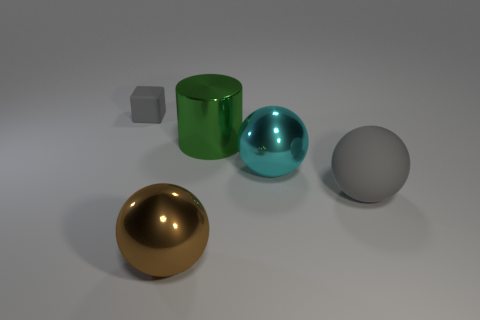Can you describe the position of the objects in the image? Certainly! In the image, we see a collection of geometric shapes positioned on a flat surface against a light background. Starting from the left, we have a golden sphere with a reflective surface, followed by a matte green cylinder, and next to it is a shiny light blue sphere. To the far right, there is a matte gray sphere. Directly in front of the green cylinder, we also observe a small matte gray cube and a larger one further behind it. 